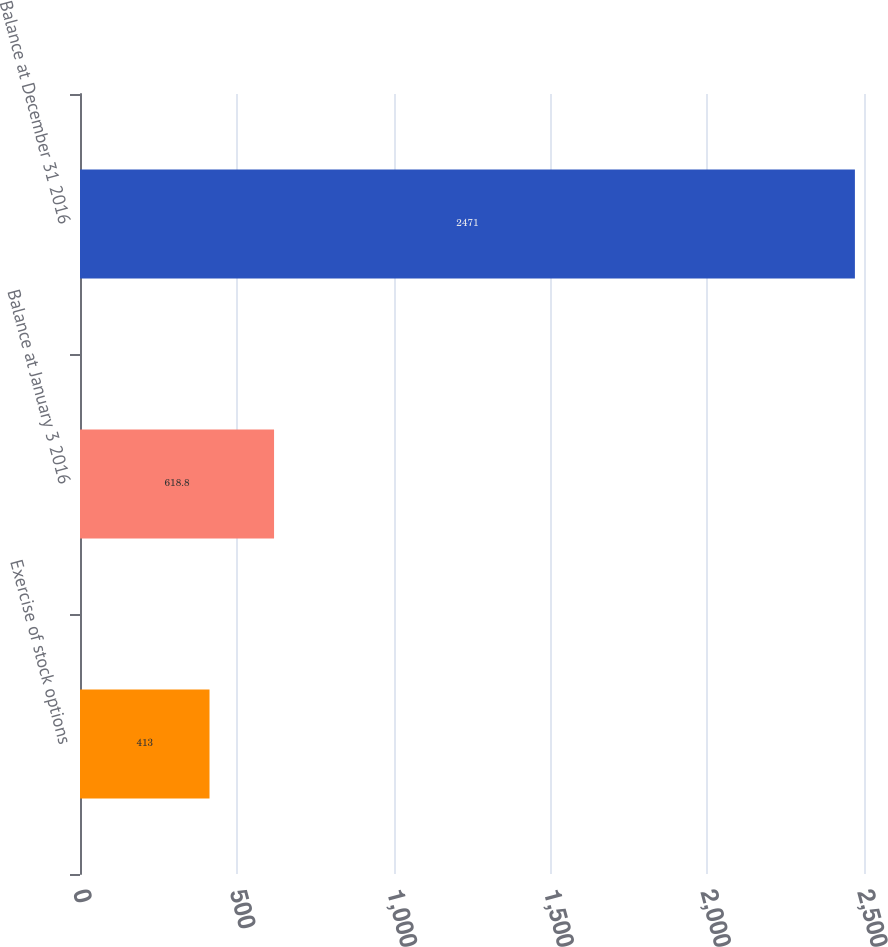<chart> <loc_0><loc_0><loc_500><loc_500><bar_chart><fcel>Exercise of stock options<fcel>Balance at January 3 2016<fcel>Balance at December 31 2016<nl><fcel>413<fcel>618.8<fcel>2471<nl></chart> 